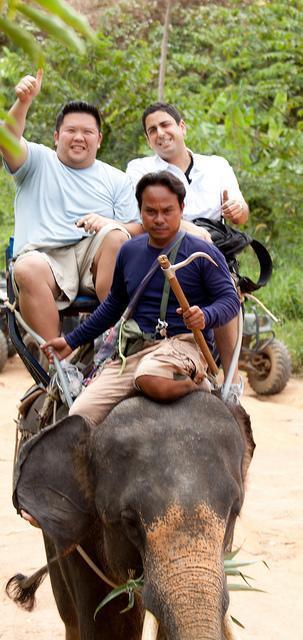How many people are on the elephant?
Give a very brief answer. 3. How many people are in the photo?
Give a very brief answer. 3. How many horses is in the picture?
Give a very brief answer. 0. 